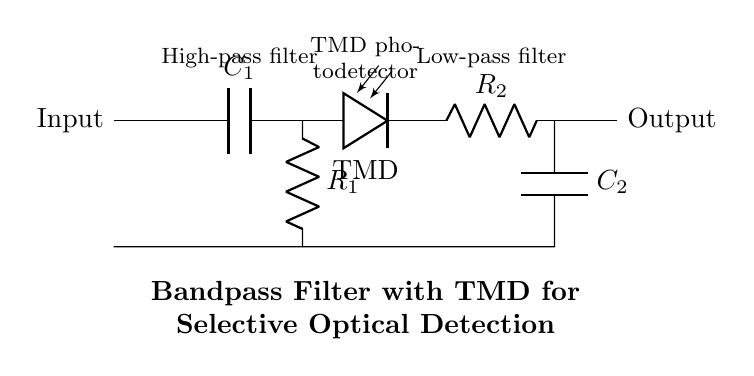What is the type of the first filter in the circuit? The first filter is a high-pass filter, as indicated in the circuit diagram where capacitors are typically associated with high-pass configurations.
Answer: High-pass filter What component follows the TMD photodetector? The TMD photodetector is followed by a resistor, which is a standard component in filtering circuits for load stabilization.
Answer: Resistor What is the role of the capacitor labeled C2? The capacitor C2 is part of the low-pass filter section, responsible for allowing low-frequency signals to pass while attenuating high-frequency signals, effectively filtering the output.
Answer: Allow low-frequency signals How does the TMD photodetector contribute to the circuit's function? The TMD photodetector converts incident optical signals into electrical signals, enabling the circuit to detect specific optical frequencies within the bandpass filtering range, crucial for spectroscopy applications.
Answer: Converts optical to electrical What is the overall function of the circuit shown? The overall function of the circuit is to selectively filter specific frequency ranges of signals for enhanced detection in optical spectroscopy, utilizing a combination of high-pass and low-pass filtering techniques.
Answer: Bandpass filtering What components constitute the high-pass filter section? The high-pass filter section is comprised of the capacitor C1 and the resistor R1, which work together to block lower frequencies and allow higher frequencies to pass through.
Answer: Capacitor C1 and Resistor R1 